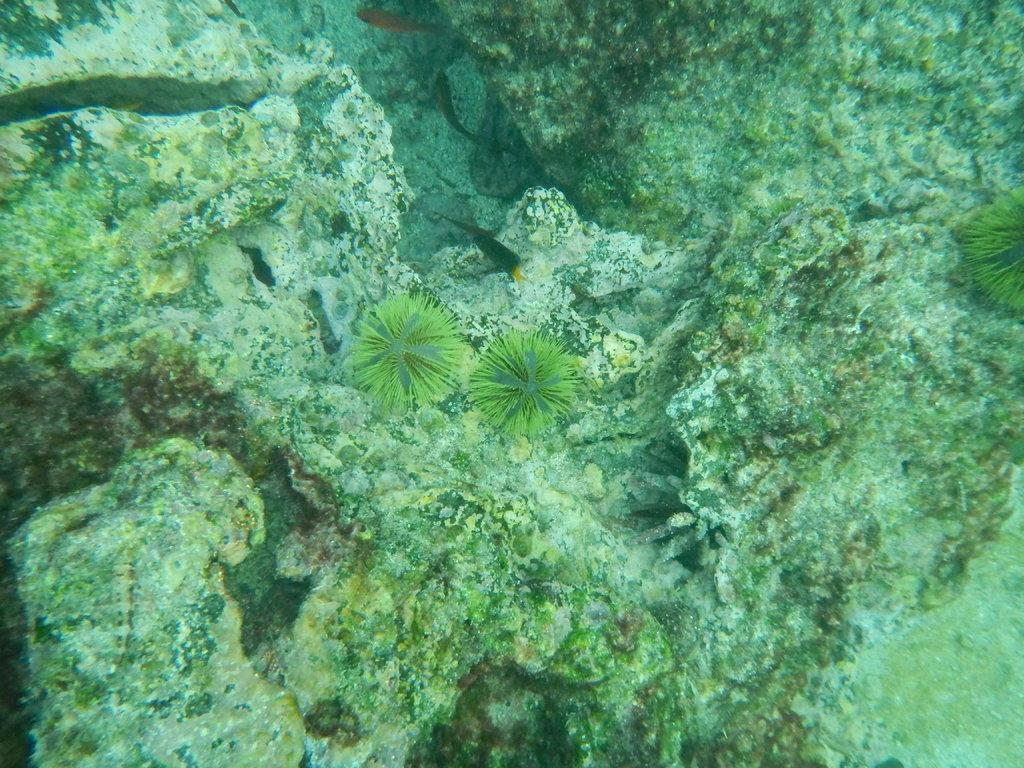What is the setting of the image? The image shows the inside of water. What types of creatures can be seen in the image? There are aquatic animals in the image. Are there any plants visible in the image? Yes, there are plants in the image. What other objects can be seen in the image? There are rocks in the image. What type of wall can be seen in the image? There is no wall present in the image; it shows the inside of water with aquatic animals, plants, and rocks. 